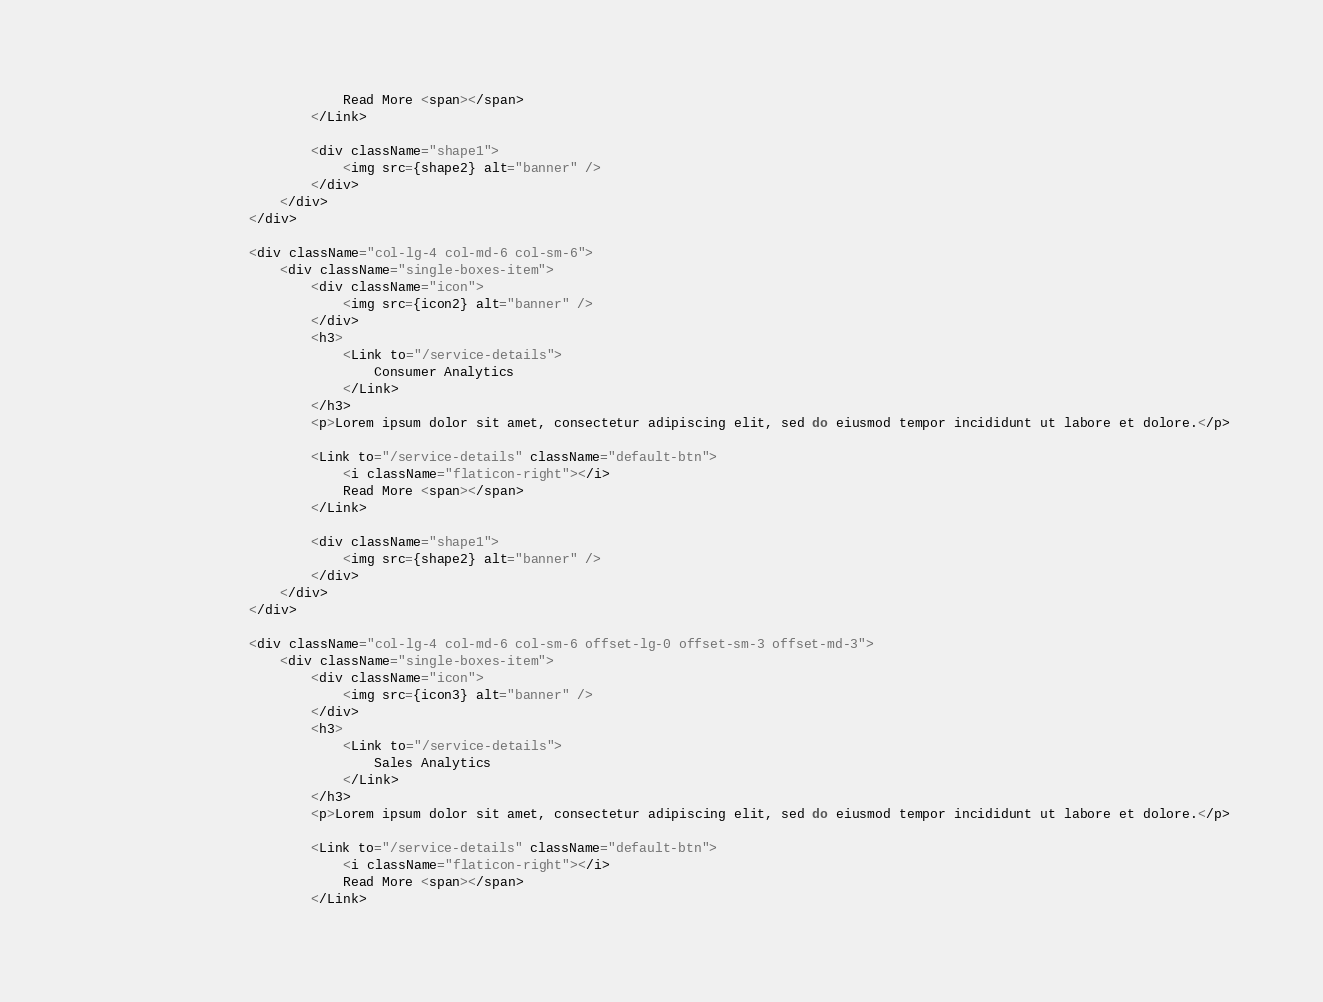<code> <loc_0><loc_0><loc_500><loc_500><_JavaScript_>                                Read More <span></span>
                            </Link>

                            <div className="shape1">
                                <img src={shape2} alt="banner" />
                            </div>
                        </div>
                    </div>

                    <div className="col-lg-4 col-md-6 col-sm-6">
                        <div className="single-boxes-item">
                            <div className="icon">
                                <img src={icon2} alt="banner" />
                            </div>
                            <h3>
                                <Link to="/service-details">
                                    Consumer Analytics
                                </Link>
                            </h3>
                            <p>Lorem ipsum dolor sit amet, consectetur adipiscing elit, sed do eiusmod tempor incididunt ut labore et dolore.</p>
                            
                            <Link to="/service-details" className="default-btn">
                                <i className="flaticon-right"></i> 
                                Read More <span></span>
                            </Link>

                            <div className="shape1">
                                <img src={shape2} alt="banner" />
                            </div>
                        </div>
                    </div>

                    <div className="col-lg-4 col-md-6 col-sm-6 offset-lg-0 offset-sm-3 offset-md-3">
                        <div className="single-boxes-item">
                            <div className="icon">
                                <img src={icon3} alt="banner" />
                            </div>
                            <h3>
                                <Link to="/service-details">
                                    Sales Analytics
                                </Link>
                            </h3>
                            <p>Lorem ipsum dolor sit amet, consectetur adipiscing elit, sed do eiusmod tempor incididunt ut labore et dolore.</p>
                            
                            <Link to="/service-details" className="default-btn">
                                <i className="flaticon-right"></i> 
                                Read More <span></span>
                            </Link>
</code> 